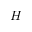Convert formula to latex. <formula><loc_0><loc_0><loc_500><loc_500>H</formula> 